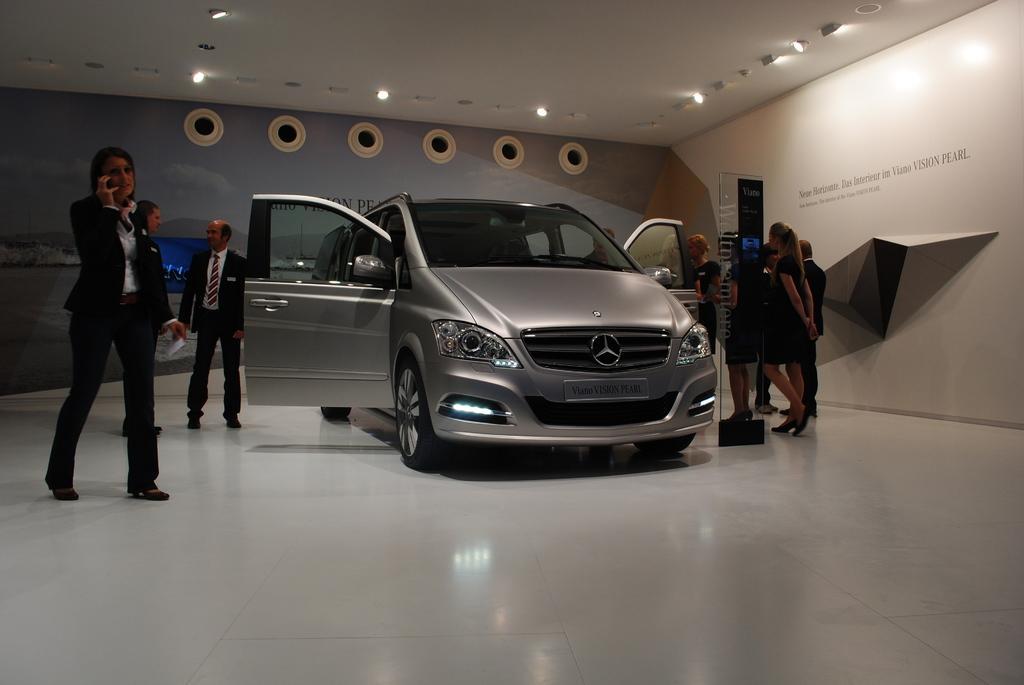Could you give a brief overview of what you see in this image? These vehicle doors are open. Beside this vehicle there are people. These are lights. 